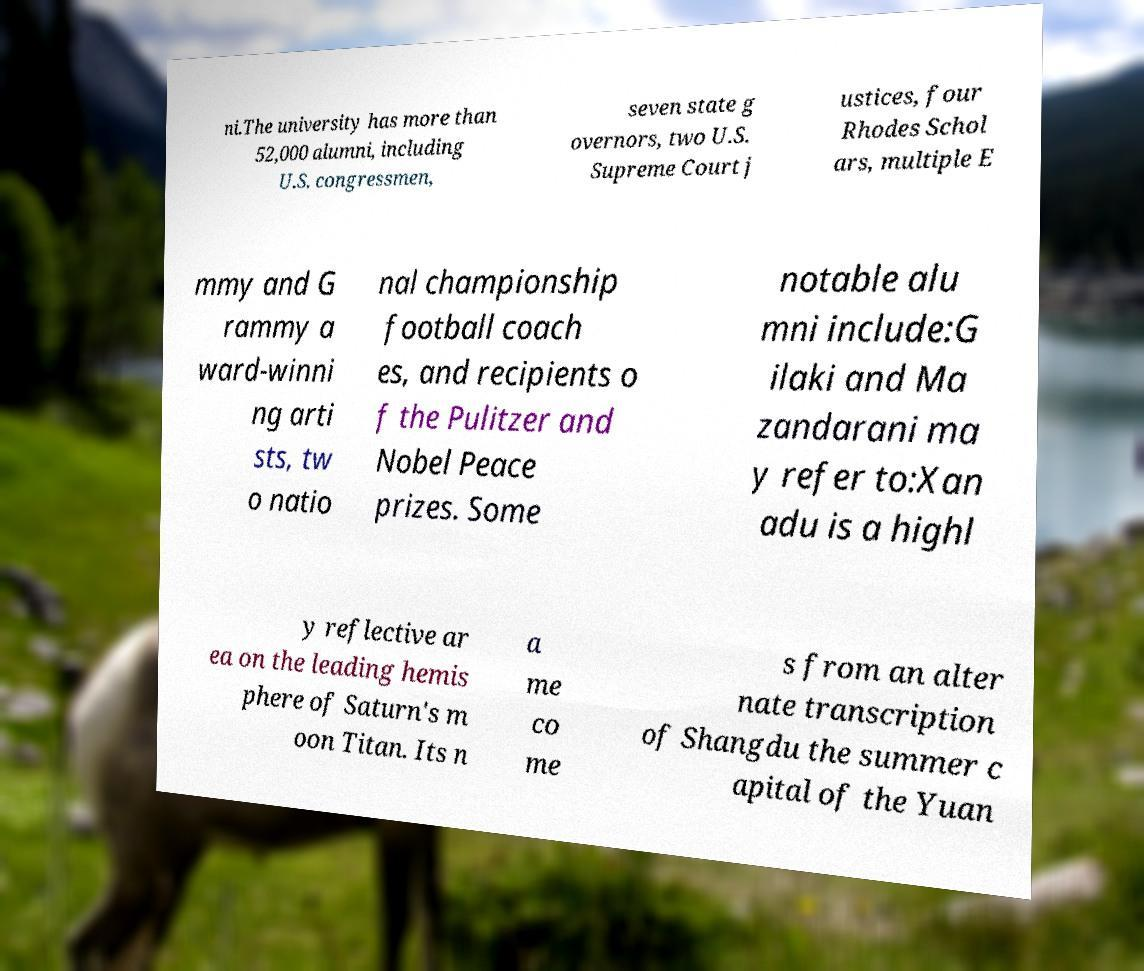Please identify and transcribe the text found in this image. ni.The university has more than 52,000 alumni, including U.S. congressmen, seven state g overnors, two U.S. Supreme Court j ustices, four Rhodes Schol ars, multiple E mmy and G rammy a ward-winni ng arti sts, tw o natio nal championship football coach es, and recipients o f the Pulitzer and Nobel Peace prizes. Some notable alu mni include:G ilaki and Ma zandarani ma y refer to:Xan adu is a highl y reflective ar ea on the leading hemis phere of Saturn's m oon Titan. Its n a me co me s from an alter nate transcription of Shangdu the summer c apital of the Yuan 